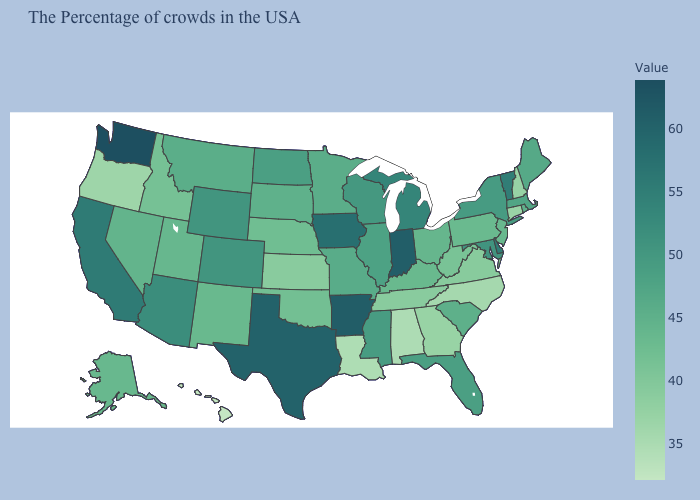Does Nebraska have a higher value than California?
Give a very brief answer. No. Which states have the lowest value in the USA?
Be succinct. Hawaii. Among the states that border Massachusetts , does Vermont have the highest value?
Short answer required. Yes. Which states have the lowest value in the South?
Answer briefly. Louisiana. Which states have the highest value in the USA?
Give a very brief answer. Washington. Does Tennessee have the highest value in the USA?
Answer briefly. No. 